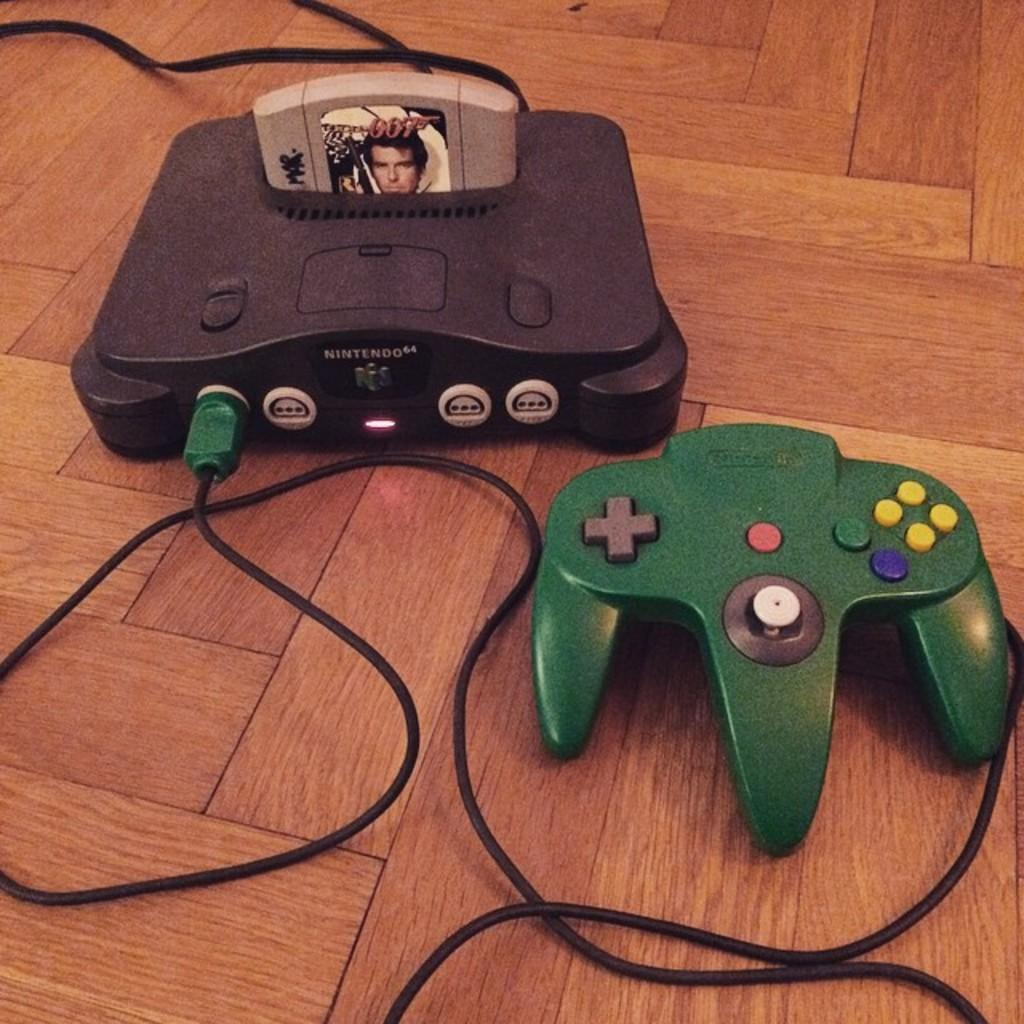What type of game controller is in the image? There is a green color game controller in the image. What else can be seen in the image besides the game controller? Cables and a game cartridge are visible in the image. What is the surface on which the objects are placed? The objects are on a wooden surface. What type of vessel is used to boil water in the image? There is no vessel or water-boiling activity present in the image. 